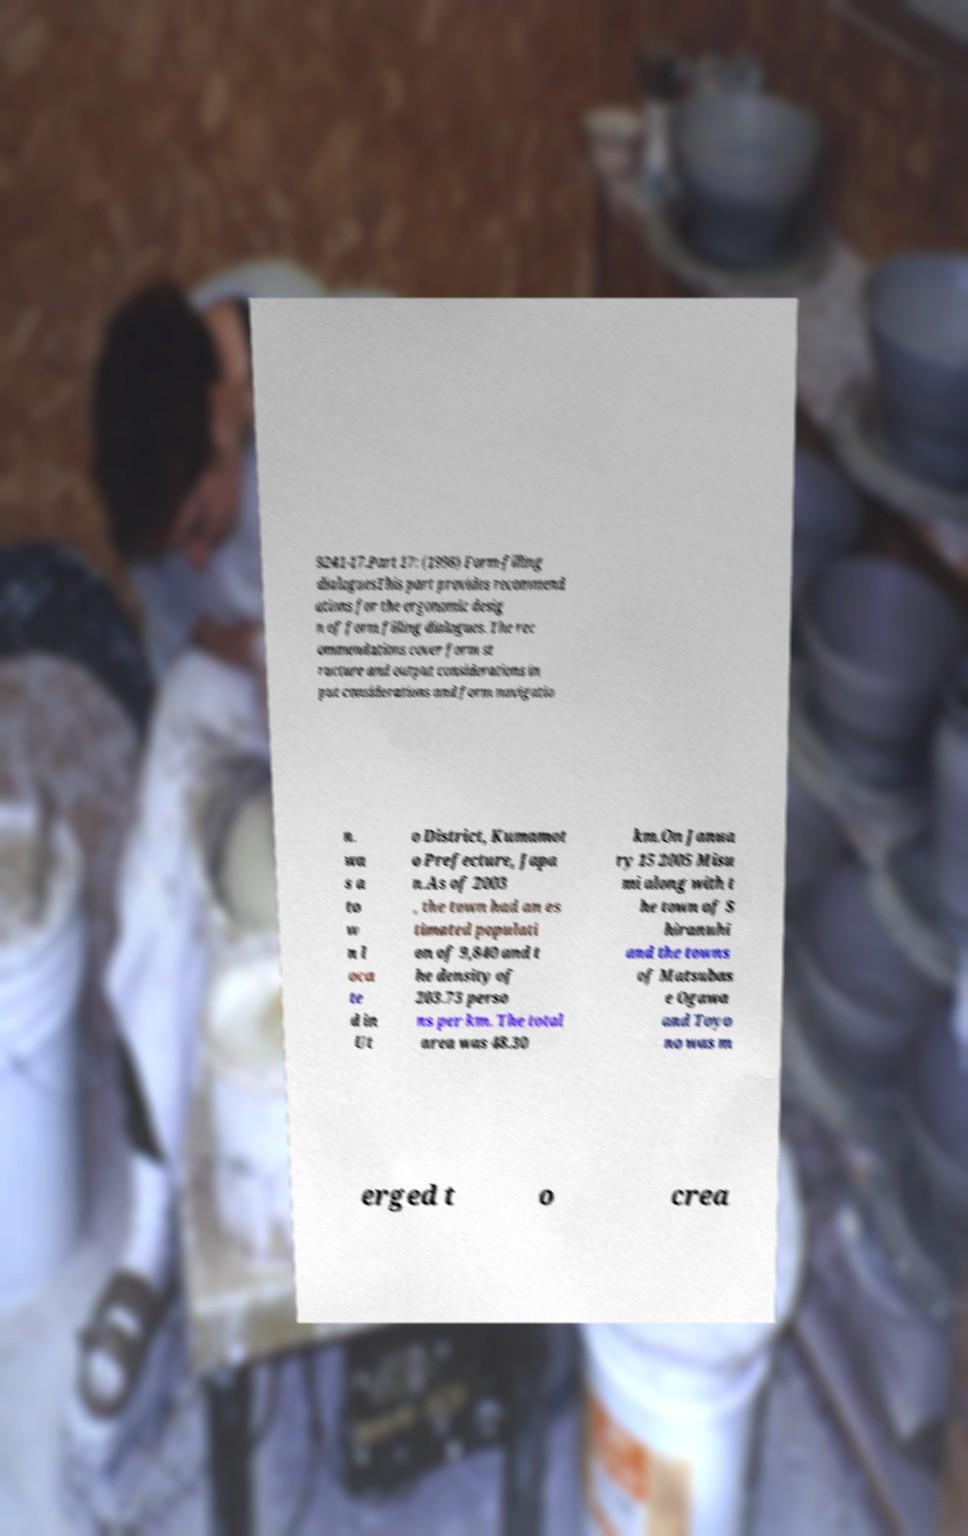Please read and relay the text visible in this image. What does it say? 9241-17.Part 17: (1998) Form-filling dialoguesThis part provides recommend ations for the ergonomic desig n of form filling dialogues. The rec ommendations cover form st ructure and output considerations in put considerations and form navigatio n. wa s a to w n l oca te d in Ut o District, Kumamot o Prefecture, Japa n.As of 2003 , the town had an es timated populati on of 9,840 and t he density of 203.73 perso ns per km. The total area was 48.30 km.On Janua ry 15 2005 Misu mi along with t he town of S hiranuhi and the towns of Matsubas e Ogawa and Toyo no was m erged t o crea 